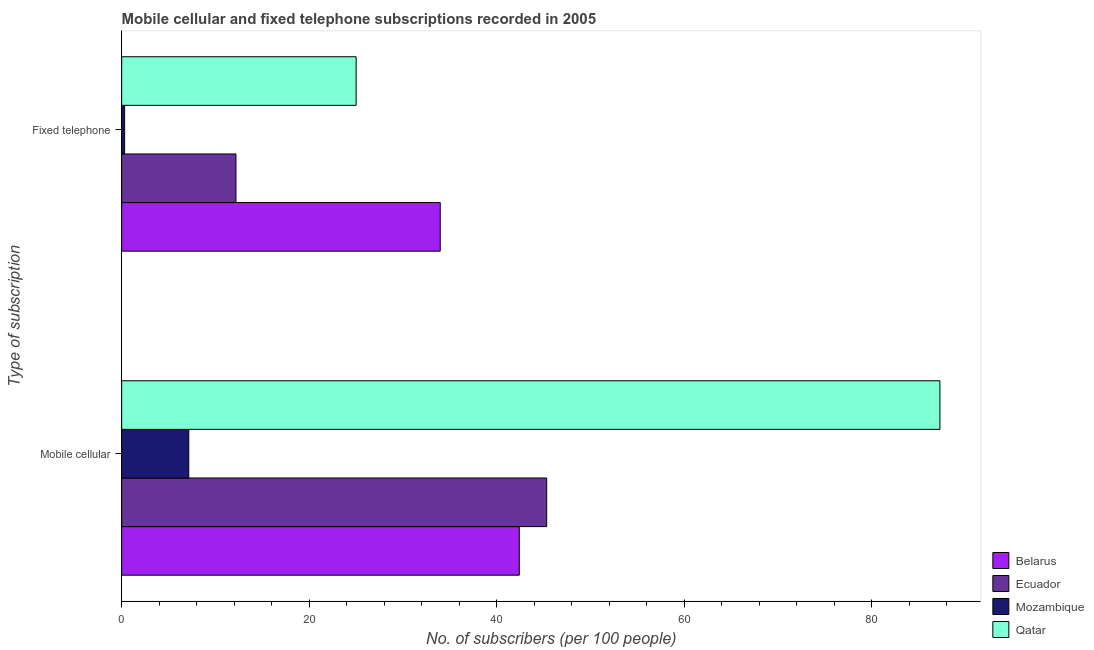How many groups of bars are there?
Ensure brevity in your answer.  2. Are the number of bars on each tick of the Y-axis equal?
Offer a terse response. Yes. How many bars are there on the 1st tick from the bottom?
Ensure brevity in your answer.  4. What is the label of the 2nd group of bars from the top?
Offer a terse response. Mobile cellular. What is the number of fixed telephone subscribers in Belarus?
Your answer should be very brief. 33.98. Across all countries, what is the maximum number of mobile cellular subscribers?
Make the answer very short. 87.29. Across all countries, what is the minimum number of mobile cellular subscribers?
Give a very brief answer. 7.16. In which country was the number of fixed telephone subscribers maximum?
Your answer should be very brief. Belarus. In which country was the number of fixed telephone subscribers minimum?
Your answer should be compact. Mozambique. What is the total number of mobile cellular subscribers in the graph?
Your response must be concise. 182.2. What is the difference between the number of fixed telephone subscribers in Belarus and that in Mozambique?
Give a very brief answer. 33.67. What is the difference between the number of mobile cellular subscribers in Belarus and the number of fixed telephone subscribers in Ecuador?
Offer a very short reply. 30.23. What is the average number of mobile cellular subscribers per country?
Ensure brevity in your answer.  45.55. What is the difference between the number of mobile cellular subscribers and number of fixed telephone subscribers in Mozambique?
Your response must be concise. 6.84. What is the ratio of the number of mobile cellular subscribers in Qatar to that in Belarus?
Provide a short and direct response. 2.06. In how many countries, is the number of fixed telephone subscribers greater than the average number of fixed telephone subscribers taken over all countries?
Offer a very short reply. 2. What does the 2nd bar from the top in Fixed telephone represents?
Your response must be concise. Mozambique. What does the 3rd bar from the bottom in Mobile cellular represents?
Provide a succinct answer. Mozambique. What is the difference between two consecutive major ticks on the X-axis?
Give a very brief answer. 20. What is the title of the graph?
Your answer should be very brief. Mobile cellular and fixed telephone subscriptions recorded in 2005. Does "French Polynesia" appear as one of the legend labels in the graph?
Your answer should be compact. No. What is the label or title of the X-axis?
Your answer should be very brief. No. of subscribers (per 100 people). What is the label or title of the Y-axis?
Provide a succinct answer. Type of subscription. What is the No. of subscribers (per 100 people) of Belarus in Mobile cellular?
Make the answer very short. 42.42. What is the No. of subscribers (per 100 people) of Ecuador in Mobile cellular?
Ensure brevity in your answer.  45.34. What is the No. of subscribers (per 100 people) of Mozambique in Mobile cellular?
Make the answer very short. 7.16. What is the No. of subscribers (per 100 people) of Qatar in Mobile cellular?
Provide a short and direct response. 87.29. What is the No. of subscribers (per 100 people) in Belarus in Fixed telephone?
Your answer should be very brief. 33.98. What is the No. of subscribers (per 100 people) in Ecuador in Fixed telephone?
Your answer should be very brief. 12.19. What is the No. of subscribers (per 100 people) of Mozambique in Fixed telephone?
Provide a succinct answer. 0.31. What is the No. of subscribers (per 100 people) of Qatar in Fixed telephone?
Your answer should be compact. 25.01. Across all Type of subscription, what is the maximum No. of subscribers (per 100 people) in Belarus?
Provide a short and direct response. 42.42. Across all Type of subscription, what is the maximum No. of subscribers (per 100 people) in Ecuador?
Keep it short and to the point. 45.34. Across all Type of subscription, what is the maximum No. of subscribers (per 100 people) in Mozambique?
Give a very brief answer. 7.16. Across all Type of subscription, what is the maximum No. of subscribers (per 100 people) of Qatar?
Offer a terse response. 87.29. Across all Type of subscription, what is the minimum No. of subscribers (per 100 people) in Belarus?
Your answer should be compact. 33.98. Across all Type of subscription, what is the minimum No. of subscribers (per 100 people) in Ecuador?
Offer a terse response. 12.19. Across all Type of subscription, what is the minimum No. of subscribers (per 100 people) in Mozambique?
Give a very brief answer. 0.31. Across all Type of subscription, what is the minimum No. of subscribers (per 100 people) in Qatar?
Make the answer very short. 25.01. What is the total No. of subscribers (per 100 people) in Belarus in the graph?
Provide a short and direct response. 76.4. What is the total No. of subscribers (per 100 people) in Ecuador in the graph?
Your answer should be compact. 57.53. What is the total No. of subscribers (per 100 people) of Mozambique in the graph?
Offer a very short reply. 7.47. What is the total No. of subscribers (per 100 people) in Qatar in the graph?
Give a very brief answer. 112.3. What is the difference between the No. of subscribers (per 100 people) of Belarus in Mobile cellular and that in Fixed telephone?
Your answer should be very brief. 8.44. What is the difference between the No. of subscribers (per 100 people) of Ecuador in Mobile cellular and that in Fixed telephone?
Offer a terse response. 33.15. What is the difference between the No. of subscribers (per 100 people) in Mozambique in Mobile cellular and that in Fixed telephone?
Keep it short and to the point. 6.84. What is the difference between the No. of subscribers (per 100 people) of Qatar in Mobile cellular and that in Fixed telephone?
Your response must be concise. 62.27. What is the difference between the No. of subscribers (per 100 people) in Belarus in Mobile cellular and the No. of subscribers (per 100 people) in Ecuador in Fixed telephone?
Give a very brief answer. 30.23. What is the difference between the No. of subscribers (per 100 people) in Belarus in Mobile cellular and the No. of subscribers (per 100 people) in Mozambique in Fixed telephone?
Offer a very short reply. 42.1. What is the difference between the No. of subscribers (per 100 people) of Belarus in Mobile cellular and the No. of subscribers (per 100 people) of Qatar in Fixed telephone?
Offer a terse response. 17.41. What is the difference between the No. of subscribers (per 100 people) in Ecuador in Mobile cellular and the No. of subscribers (per 100 people) in Mozambique in Fixed telephone?
Offer a very short reply. 45.02. What is the difference between the No. of subscribers (per 100 people) in Ecuador in Mobile cellular and the No. of subscribers (per 100 people) in Qatar in Fixed telephone?
Your response must be concise. 20.33. What is the difference between the No. of subscribers (per 100 people) in Mozambique in Mobile cellular and the No. of subscribers (per 100 people) in Qatar in Fixed telephone?
Your answer should be compact. -17.85. What is the average No. of subscribers (per 100 people) of Belarus per Type of subscription?
Your response must be concise. 38.2. What is the average No. of subscribers (per 100 people) of Ecuador per Type of subscription?
Your answer should be compact. 28.76. What is the average No. of subscribers (per 100 people) in Mozambique per Type of subscription?
Offer a very short reply. 3.74. What is the average No. of subscribers (per 100 people) of Qatar per Type of subscription?
Your response must be concise. 56.15. What is the difference between the No. of subscribers (per 100 people) in Belarus and No. of subscribers (per 100 people) in Ecuador in Mobile cellular?
Make the answer very short. -2.92. What is the difference between the No. of subscribers (per 100 people) of Belarus and No. of subscribers (per 100 people) of Mozambique in Mobile cellular?
Offer a terse response. 35.26. What is the difference between the No. of subscribers (per 100 people) of Belarus and No. of subscribers (per 100 people) of Qatar in Mobile cellular?
Offer a terse response. -44.87. What is the difference between the No. of subscribers (per 100 people) of Ecuador and No. of subscribers (per 100 people) of Mozambique in Mobile cellular?
Your response must be concise. 38.18. What is the difference between the No. of subscribers (per 100 people) in Ecuador and No. of subscribers (per 100 people) in Qatar in Mobile cellular?
Your answer should be compact. -41.95. What is the difference between the No. of subscribers (per 100 people) of Mozambique and No. of subscribers (per 100 people) of Qatar in Mobile cellular?
Offer a very short reply. -80.13. What is the difference between the No. of subscribers (per 100 people) of Belarus and No. of subscribers (per 100 people) of Ecuador in Fixed telephone?
Offer a very short reply. 21.79. What is the difference between the No. of subscribers (per 100 people) of Belarus and No. of subscribers (per 100 people) of Mozambique in Fixed telephone?
Your answer should be compact. 33.67. What is the difference between the No. of subscribers (per 100 people) in Belarus and No. of subscribers (per 100 people) in Qatar in Fixed telephone?
Ensure brevity in your answer.  8.97. What is the difference between the No. of subscribers (per 100 people) in Ecuador and No. of subscribers (per 100 people) in Mozambique in Fixed telephone?
Ensure brevity in your answer.  11.88. What is the difference between the No. of subscribers (per 100 people) of Ecuador and No. of subscribers (per 100 people) of Qatar in Fixed telephone?
Make the answer very short. -12.82. What is the difference between the No. of subscribers (per 100 people) in Mozambique and No. of subscribers (per 100 people) in Qatar in Fixed telephone?
Give a very brief answer. -24.7. What is the ratio of the No. of subscribers (per 100 people) in Belarus in Mobile cellular to that in Fixed telephone?
Keep it short and to the point. 1.25. What is the ratio of the No. of subscribers (per 100 people) of Ecuador in Mobile cellular to that in Fixed telephone?
Your answer should be very brief. 3.72. What is the ratio of the No. of subscribers (per 100 people) in Mozambique in Mobile cellular to that in Fixed telephone?
Give a very brief answer. 22.79. What is the ratio of the No. of subscribers (per 100 people) in Qatar in Mobile cellular to that in Fixed telephone?
Your answer should be very brief. 3.49. What is the difference between the highest and the second highest No. of subscribers (per 100 people) in Belarus?
Your response must be concise. 8.44. What is the difference between the highest and the second highest No. of subscribers (per 100 people) of Ecuador?
Your answer should be compact. 33.15. What is the difference between the highest and the second highest No. of subscribers (per 100 people) of Mozambique?
Ensure brevity in your answer.  6.84. What is the difference between the highest and the second highest No. of subscribers (per 100 people) of Qatar?
Provide a succinct answer. 62.27. What is the difference between the highest and the lowest No. of subscribers (per 100 people) of Belarus?
Provide a short and direct response. 8.44. What is the difference between the highest and the lowest No. of subscribers (per 100 people) of Ecuador?
Your answer should be compact. 33.15. What is the difference between the highest and the lowest No. of subscribers (per 100 people) of Mozambique?
Offer a terse response. 6.84. What is the difference between the highest and the lowest No. of subscribers (per 100 people) in Qatar?
Provide a short and direct response. 62.27. 